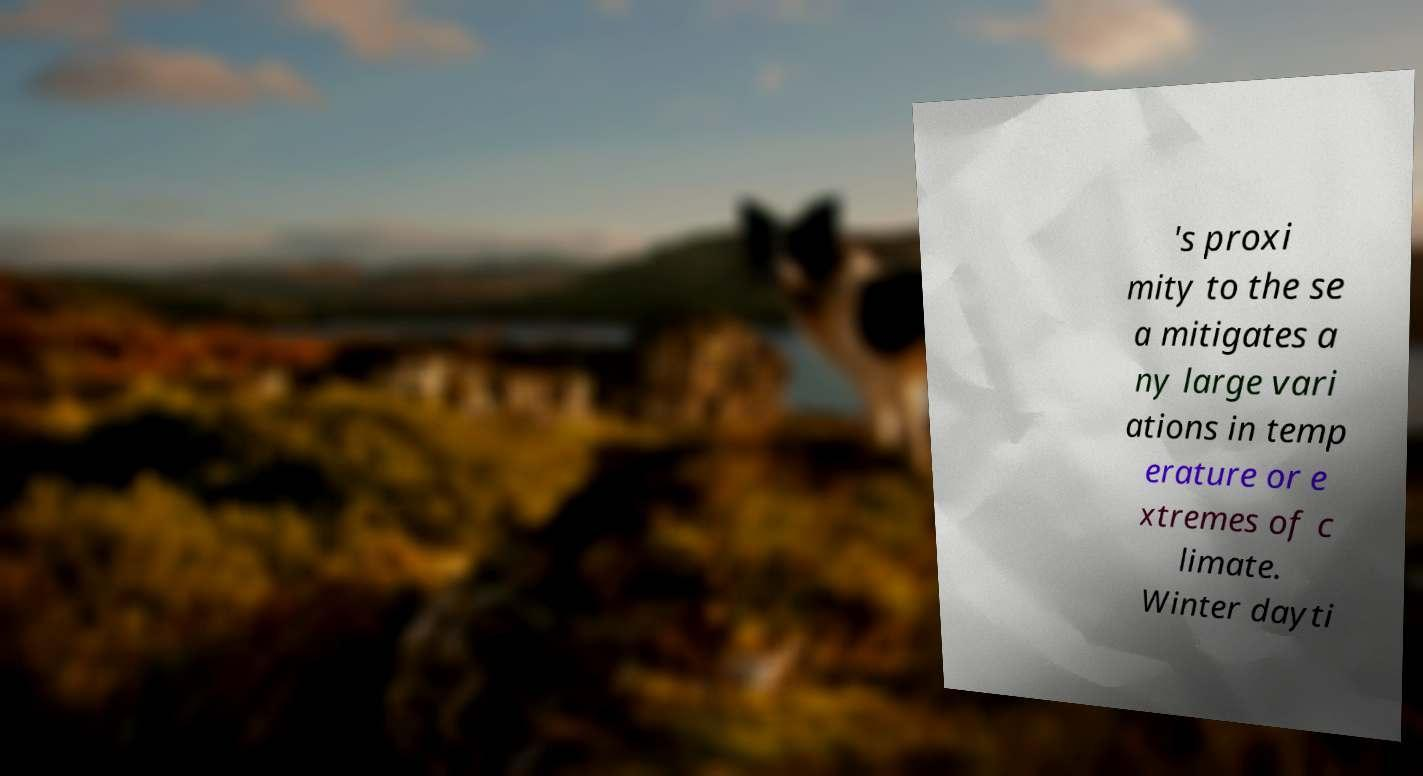Can you read and provide the text displayed in the image?This photo seems to have some interesting text. Can you extract and type it out for me? 's proxi mity to the se a mitigates a ny large vari ations in temp erature or e xtremes of c limate. Winter dayti 